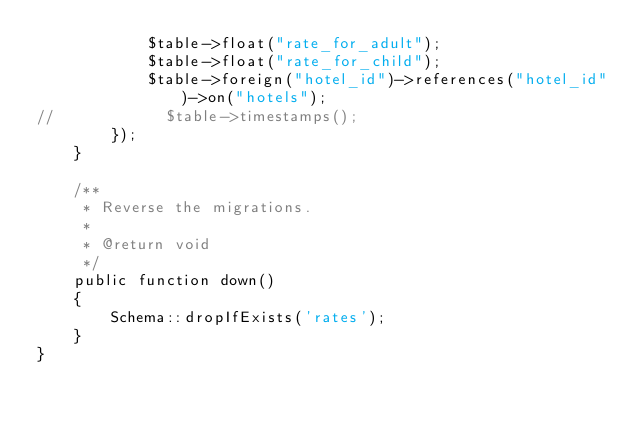<code> <loc_0><loc_0><loc_500><loc_500><_PHP_>            $table->float("rate_for_adult");
            $table->float("rate_for_child");
            $table->foreign("hotel_id")->references("hotel_id")->on("hotels");
//            $table->timestamps();
        });
    }

    /**
     * Reverse the migrations.
     *
     * @return void
     */
    public function down()
    {
        Schema::dropIfExists('rates');
    }
}
</code> 